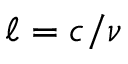Convert formula to latex. <formula><loc_0><loc_0><loc_500><loc_500>\ell = c / \nu</formula> 